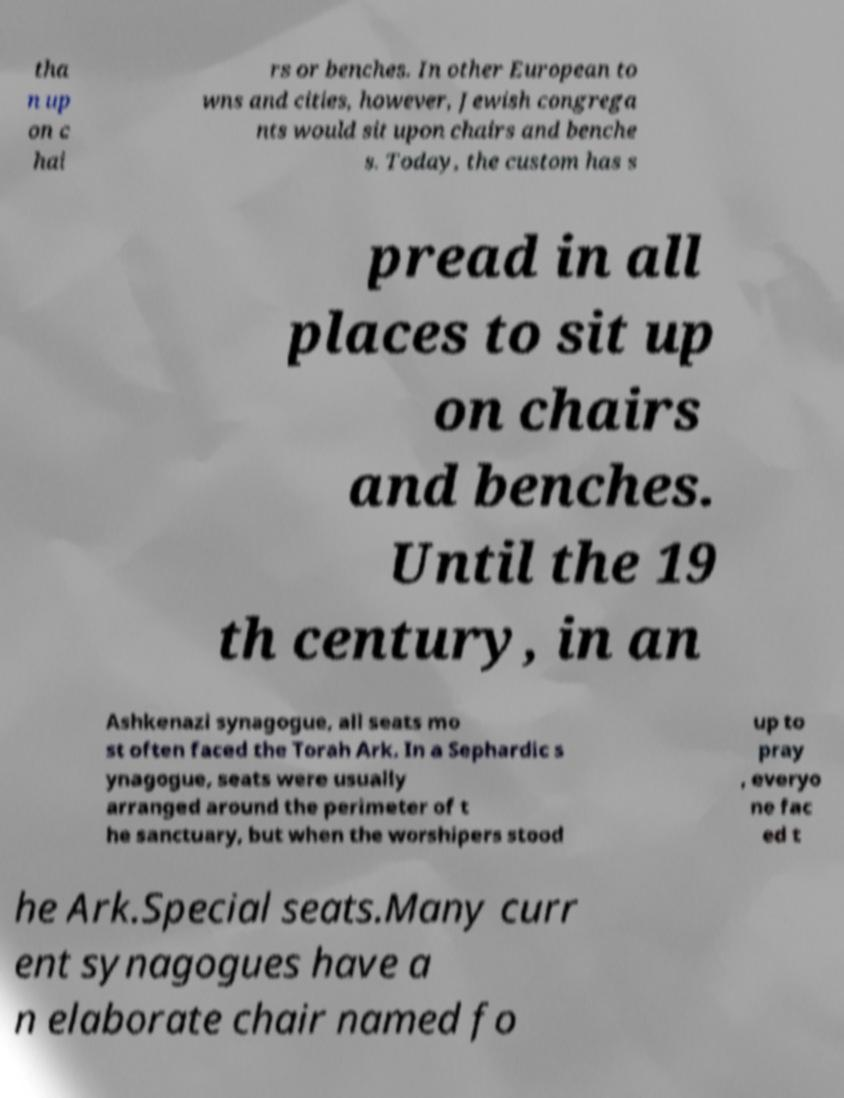Can you accurately transcribe the text from the provided image for me? tha n up on c hai rs or benches. In other European to wns and cities, however, Jewish congrega nts would sit upon chairs and benche s. Today, the custom has s pread in all places to sit up on chairs and benches. Until the 19 th century, in an Ashkenazi synagogue, all seats mo st often faced the Torah Ark. In a Sephardic s ynagogue, seats were usually arranged around the perimeter of t he sanctuary, but when the worshipers stood up to pray , everyo ne fac ed t he Ark.Special seats.Many curr ent synagogues have a n elaborate chair named fo 